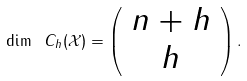Convert formula to latex. <formula><loc_0><loc_0><loc_500><loc_500>\dim \ { C _ { h } ( \mathcal { X } ) } = \left ( \begin{array} { c } n + h \\ h \end{array} \right ) .</formula> 